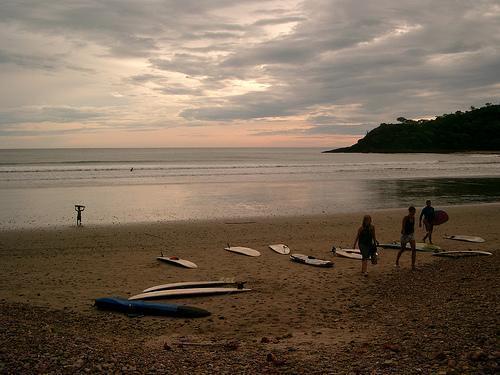How many surfboards on the sand?
Give a very brief answer. 12. How many people are on the beach by the surfboards?
Give a very brief answer. 3. How many people are in the picture?
Give a very brief answer. 5. How many people are in the water?
Give a very brief answer. 2. 